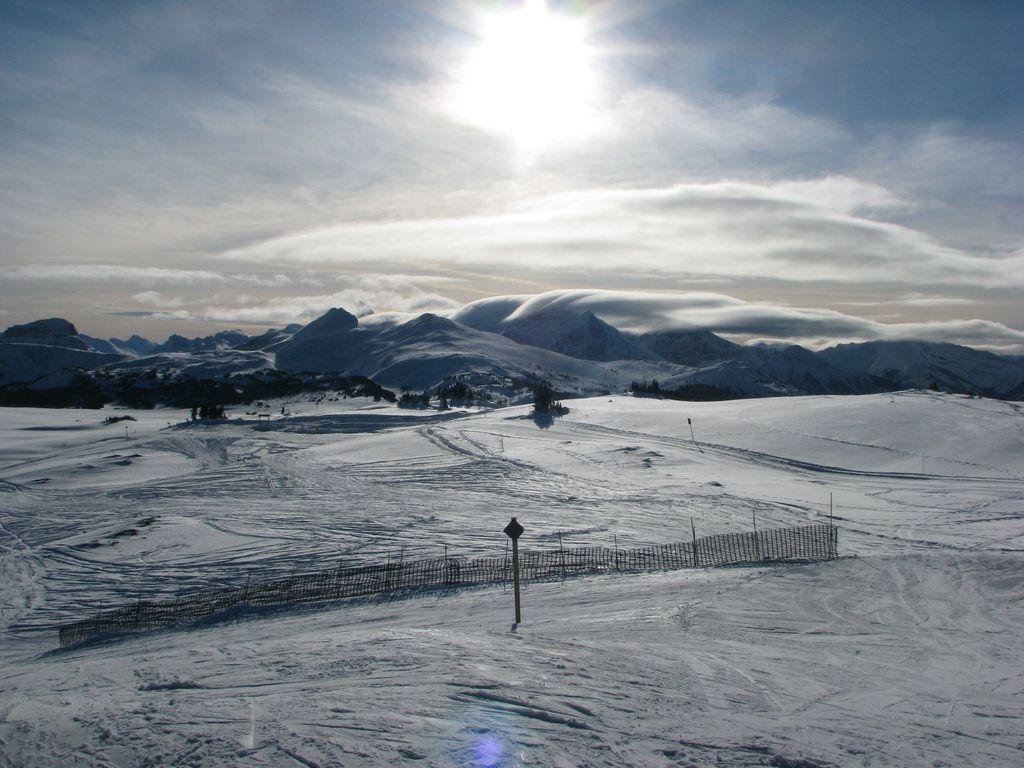Describe this image in one or two sentences. We can see snow and fence. Background we can see hills and sky with clouds. 